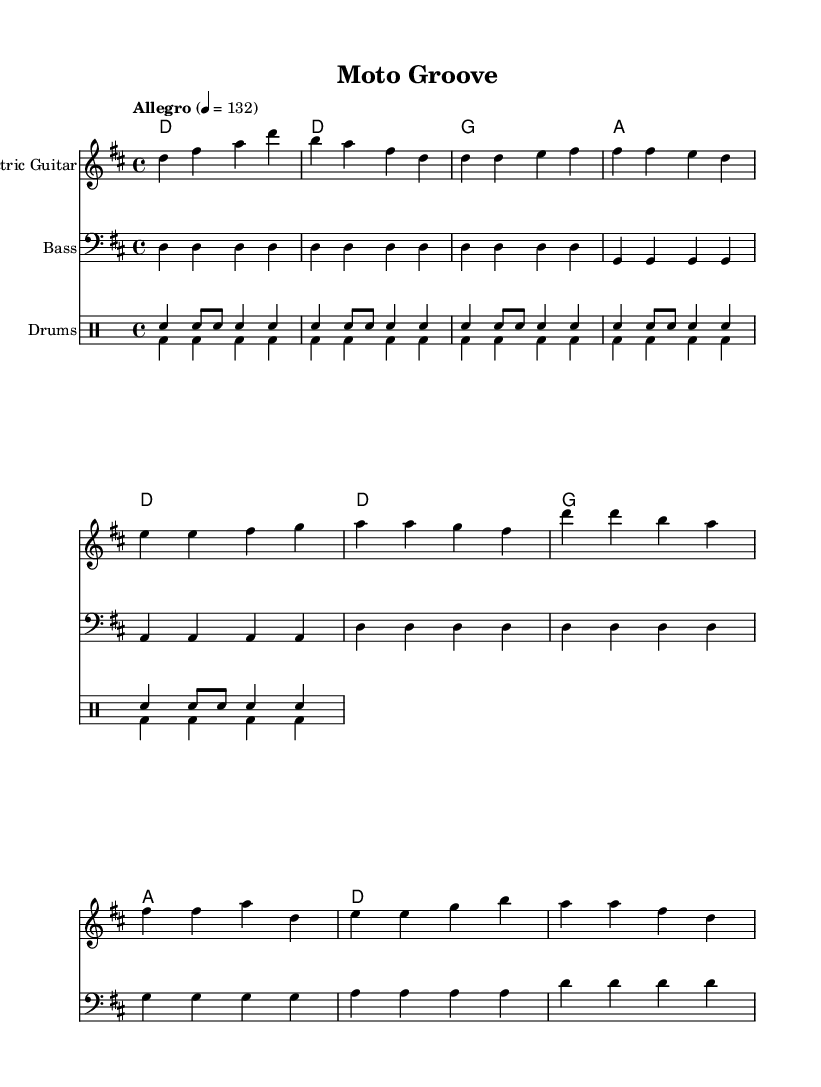What is the key signature of this music? The key signature indicates two sharps. It can be identified by the presence of F# and C# on the staff.
Answer: D major What is the time signature of the piece? The time signature is indicated in the beginning of the music sheet and is written as 4/4. This means there are four beats in a measure and the quarter note gets one beat.
Answer: 4/4 What is the tempo marking for this composition? The tempo marking is given at the top of the score and it states "Allegro" with a metronome mark of 132 beats per minute.
Answer: 132 What instruments are featured in this score? The score lists three instruments: Electric Guitar, Bass, and Drums. This can be seen in the respective staff labels at the beginning of each line.
Answer: Electric Guitar, Bass, Drums How many measures are in the chorus section? To determine the number of measures in the chorus, we look at the section labeled as "Chorus". Counting the measures gives a total of four measures.
Answer: 4 What chords are used in the verse section? The chords listed for the verse are D major and G major. These can be found in the chord names section, denoted next to the corresponding measures of the verse.
Answer: D, G Which rhythmic pattern is used for the snare drum in the intro? The rhythmic pattern for the snare drum in the intro is characterized by one quarter note followed by two eighth notes, repeating, which is reflected in the drumming section labeled "sn".
Answer: sn4 sn8 